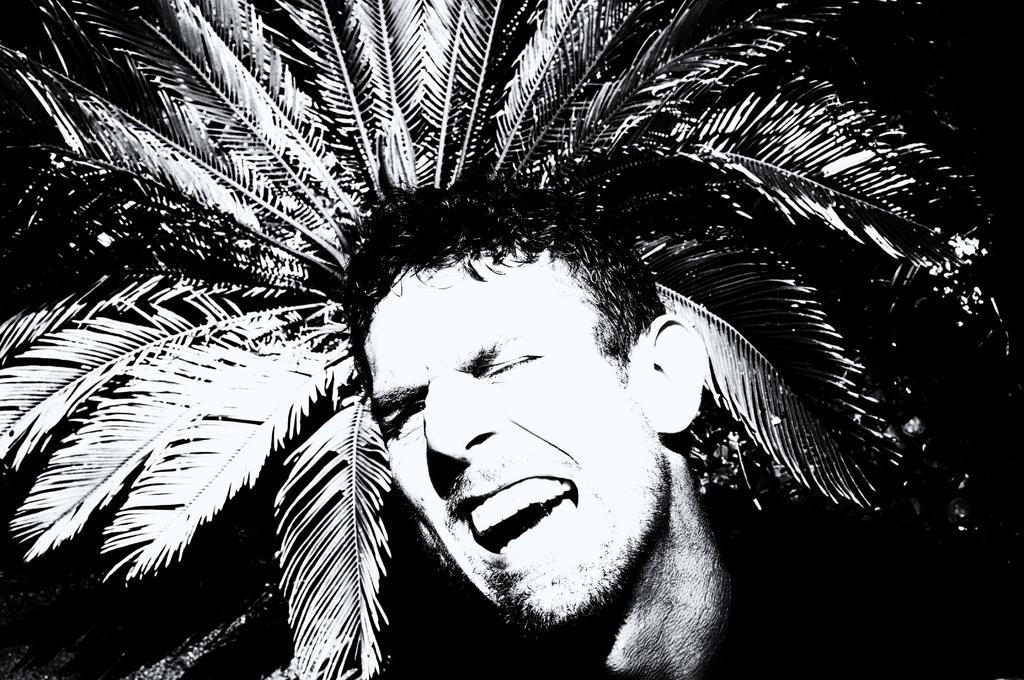Describe this image in one or two sentences. As we can see in the image there is a man wearing black color jacket and there is a tree. The image is little dark. 